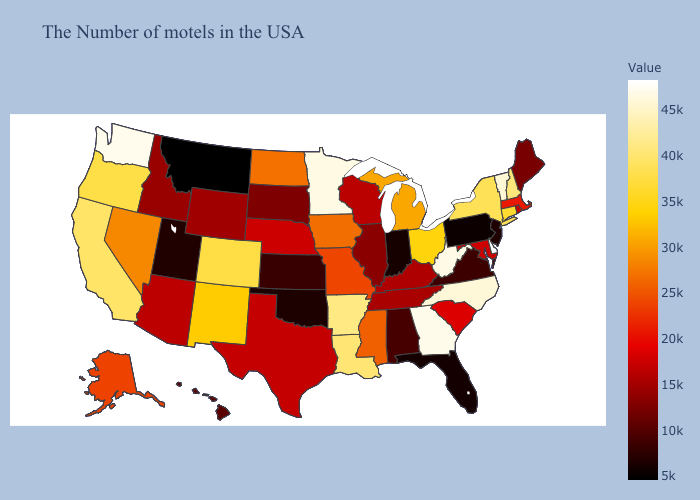Which states hav the highest value in the Northeast?
Concise answer only. Vermont. Does Illinois have a lower value than Montana?
Keep it brief. No. Among the states that border Minnesota , which have the highest value?
Short answer required. North Dakota. Does New Mexico have the lowest value in the USA?
Answer briefly. No. Which states hav the highest value in the MidWest?
Be succinct. Minnesota. Does New Jersey have the highest value in the USA?
Concise answer only. No. Which states have the highest value in the USA?
Answer briefly. Delaware. Which states hav the highest value in the West?
Quick response, please. Washington. 